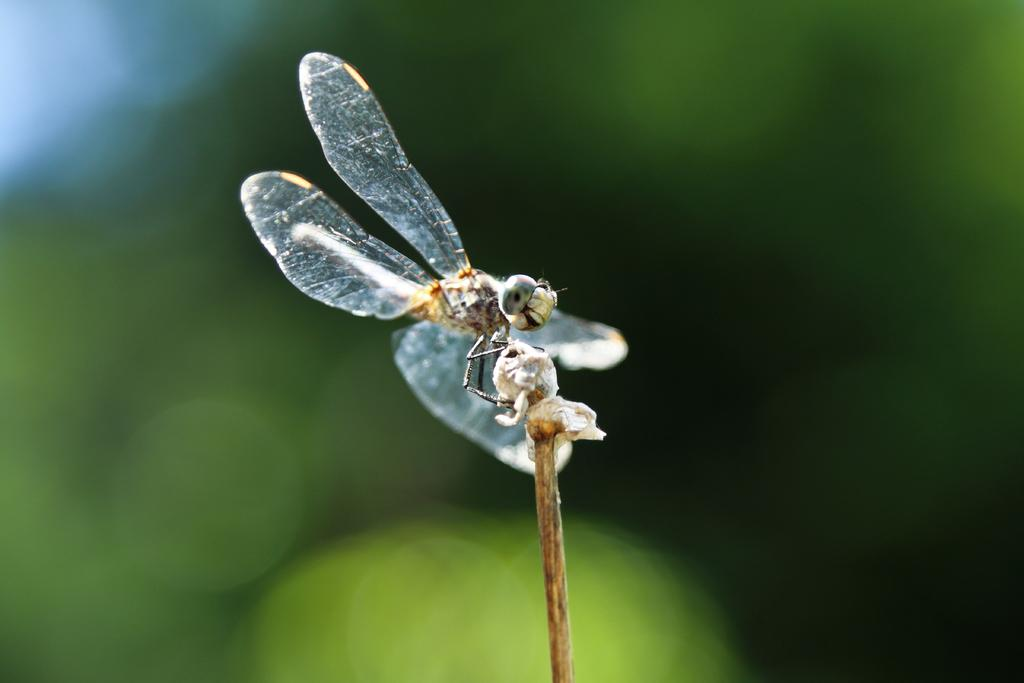What is the main subject of the image? The main subject of the image is a dragonfly representation. What is the monthly income of the dragonfly in the image? There is no indication of income in the image, as it features a dragonfly representation and not a living creature with an income. 